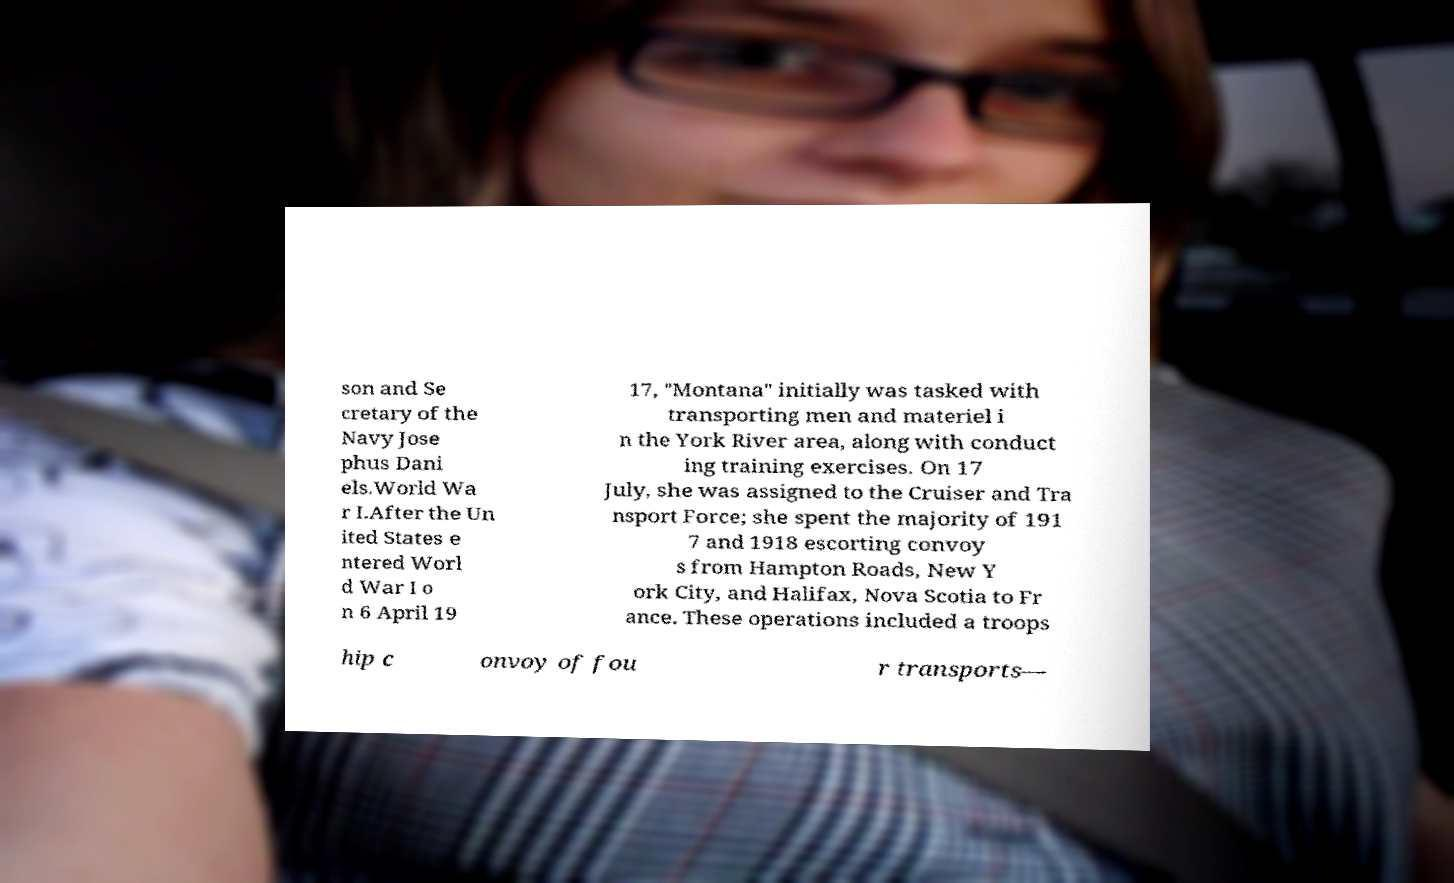What messages or text are displayed in this image? I need them in a readable, typed format. son and Se cretary of the Navy Jose phus Dani els.World Wa r I.After the Un ited States e ntered Worl d War I o n 6 April 19 17, "Montana" initially was tasked with transporting men and materiel i n the York River area, along with conduct ing training exercises. On 17 July, she was assigned to the Cruiser and Tra nsport Force; she spent the majority of 191 7 and 1918 escorting convoy s from Hampton Roads, New Y ork City, and Halifax, Nova Scotia to Fr ance. These operations included a troops hip c onvoy of fou r transports— 